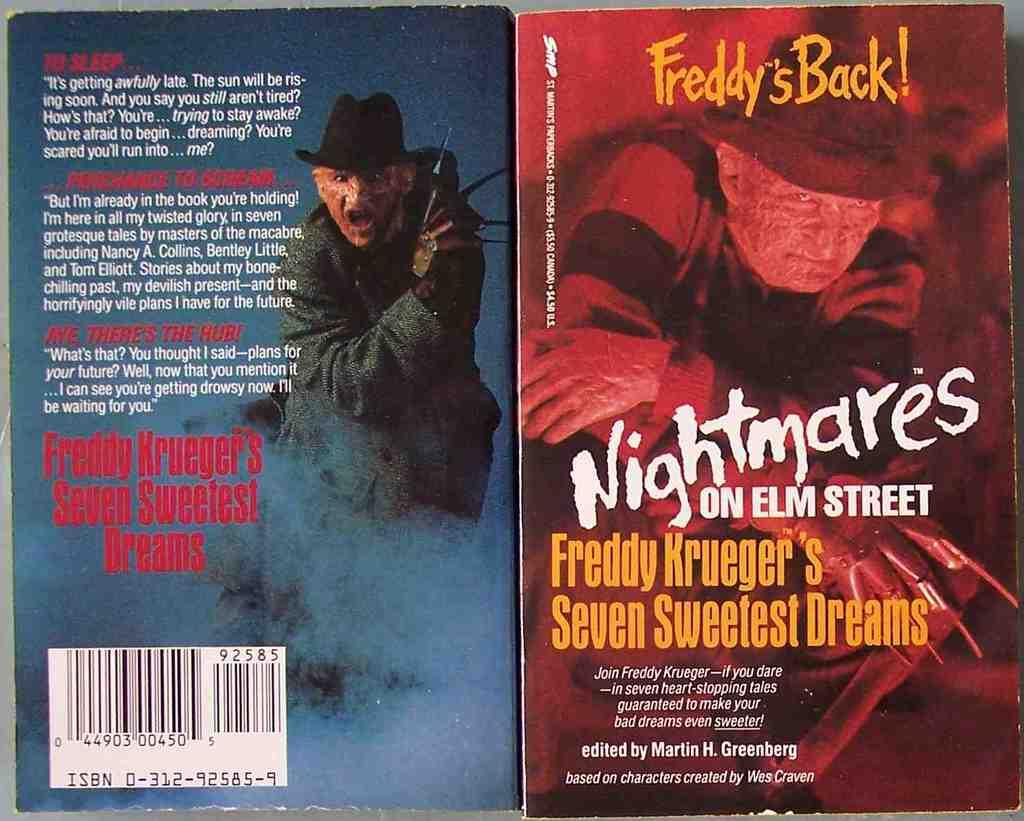Provide a one-sentence caption for the provided image. A couple of horror paperbacks are based on the Nightmare on Elm Street movies. 